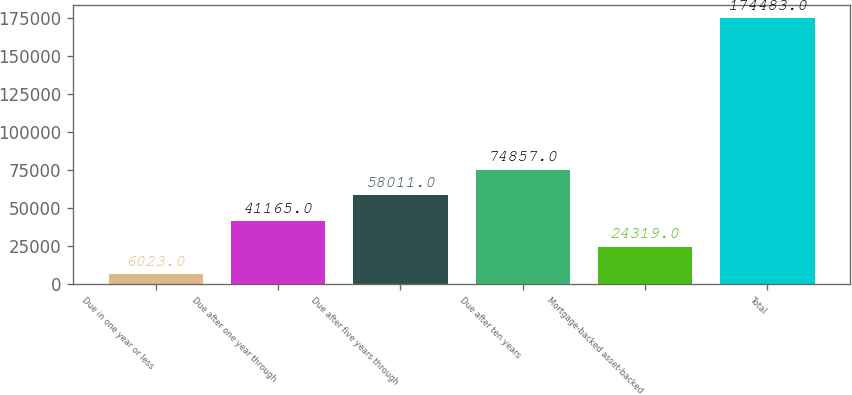<chart> <loc_0><loc_0><loc_500><loc_500><bar_chart><fcel>Due in one year or less<fcel>Due after one year through<fcel>Due after five years through<fcel>Due after ten years<fcel>Mortgage-backed asset-backed<fcel>Total<nl><fcel>6023<fcel>41165<fcel>58011<fcel>74857<fcel>24319<fcel>174483<nl></chart> 